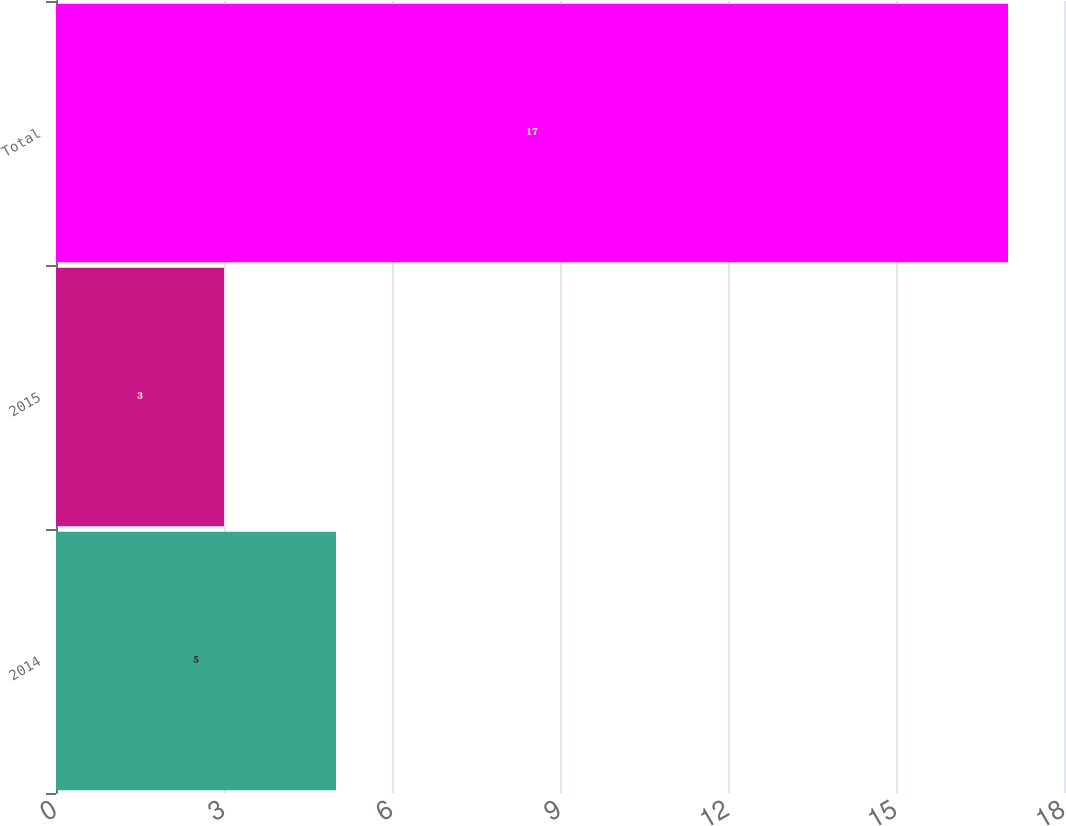<chart> <loc_0><loc_0><loc_500><loc_500><bar_chart><fcel>2014<fcel>2015<fcel>Total<nl><fcel>5<fcel>3<fcel>17<nl></chart> 